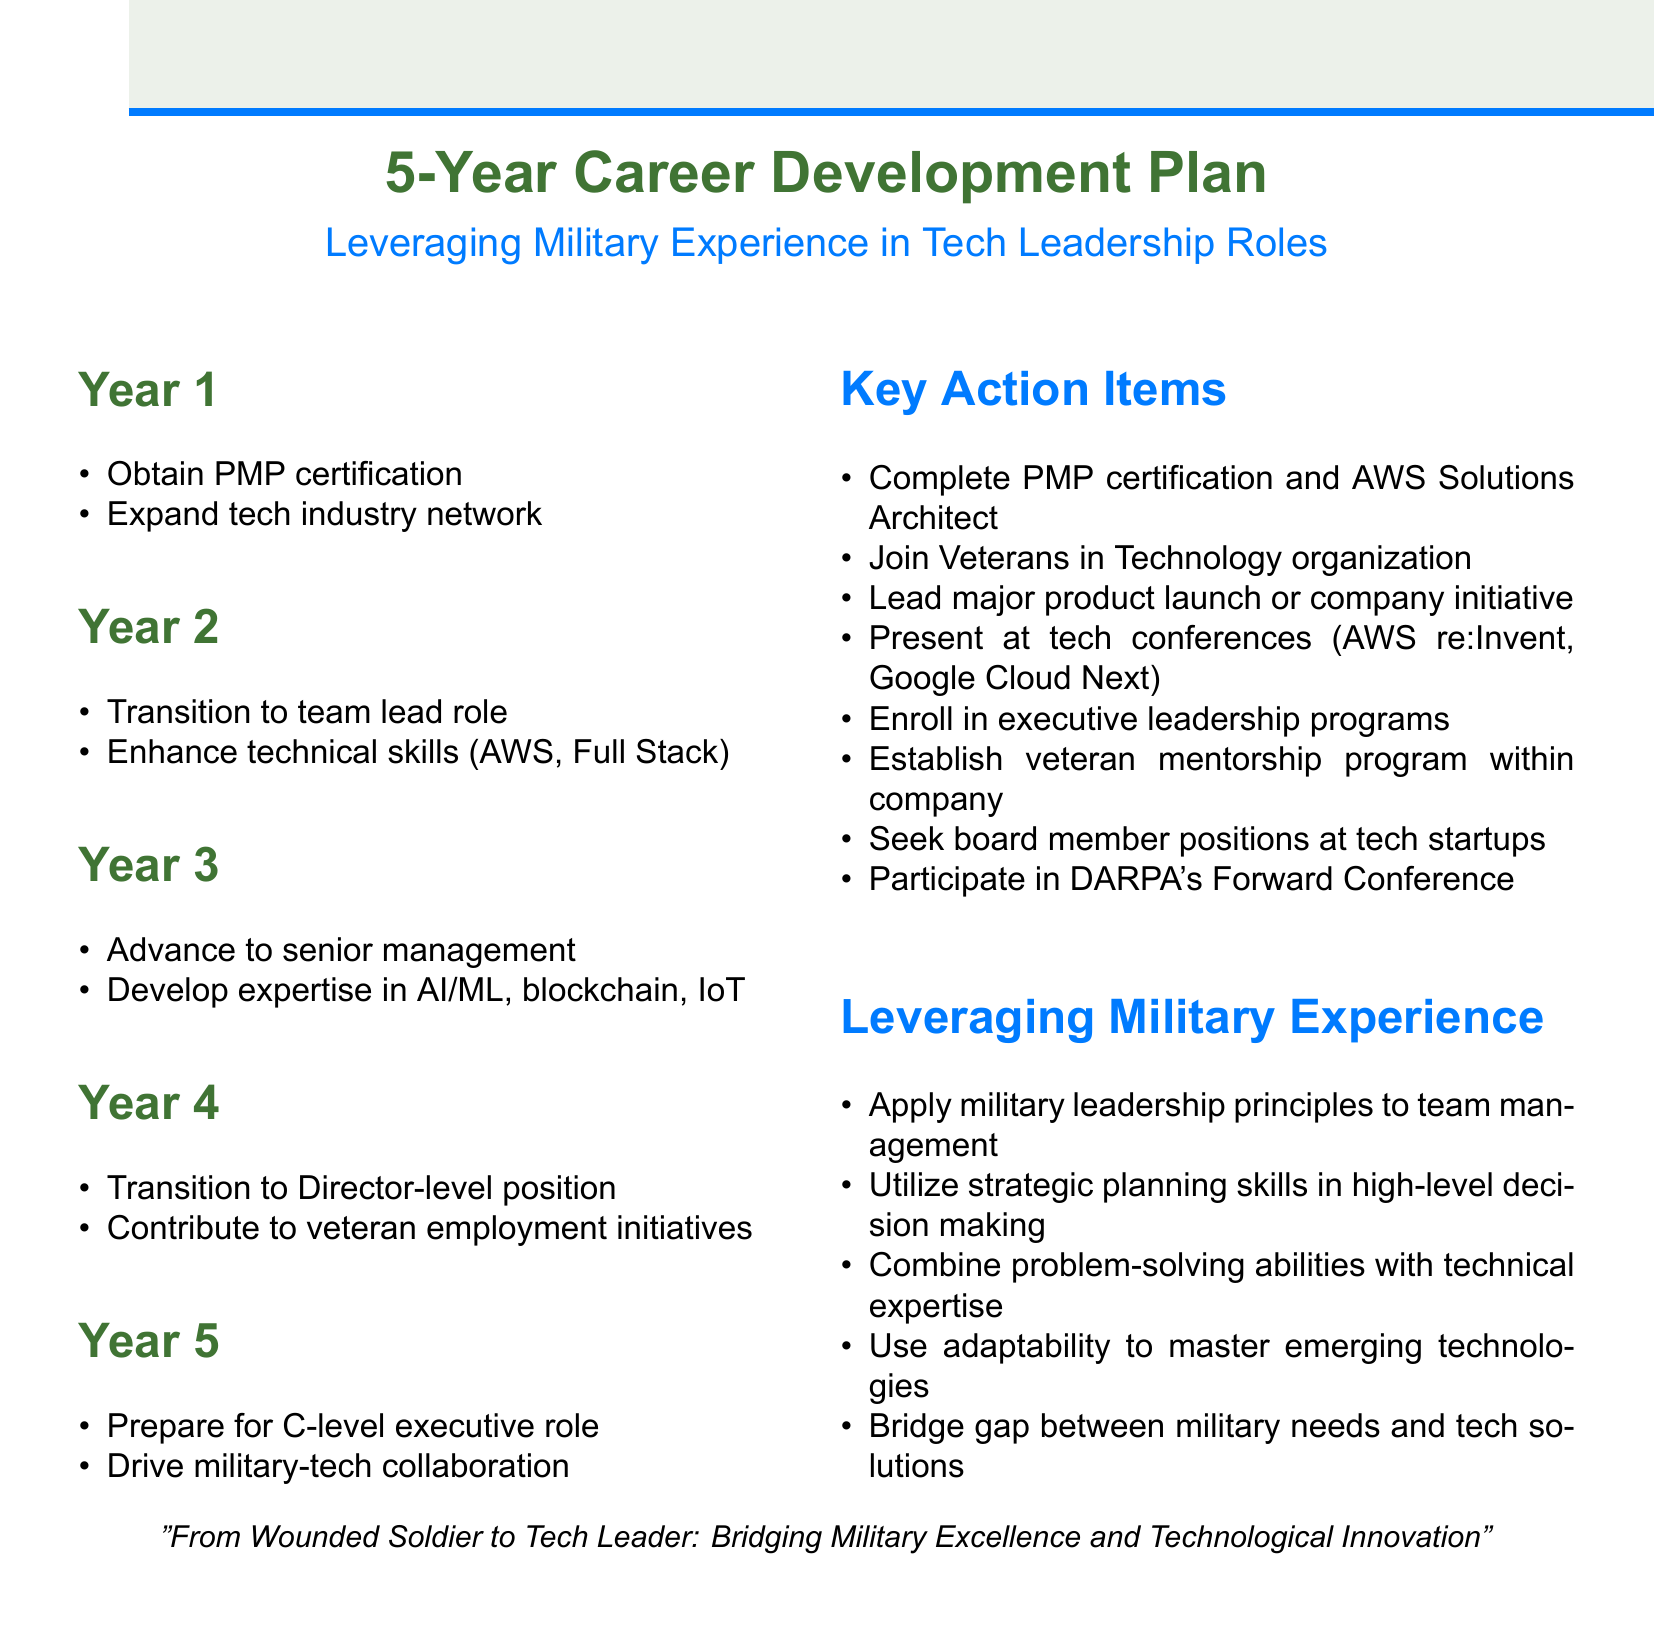What certification is targeted in Year 1? In Year 1, the goal is to obtain the Project Management Professional (PMP) certification.
Answer: PMP certification What initiative is mentioned for veteran employment in Year 4? In Year 4, the document mentions contributing to veteran employment initiatives such as partnering with Hire Heroes USA.
Answer: Veteran employment initiatives Which technology is focused on in Year 3? In Year 3, the focus is on developing expertise in emerging technologies such as artificial intelligence and machine learning.
Answer: Artificial intelligence and machine learning What is one action item for enhancing technical skills in Year 2? One of the action items listed for enhancing technical skills in Year 2 is obtaining the AWS Certified Solutions Architect certification.
Answer: AWS Certified Solutions Architect certification What is the main aim of Year 5? The main aim of Year 5 is to prepare for a C-level executive role.
Answer: C-level executive role Which organization should be joined in Year 1? The organization that should be joined in Year 1 is Veterans in Technology (VIT).
Answer: Veterans in Technology (VIT) How many years does this career development plan cover? The career development plan covers a total of five years.
Answer: Five years What is a key action item to contribute to military-tech collaboration? A key action item to contribute to military-tech collaboration is participating in DARPA's Forward Conference.
Answer: DARPA's Forward Conference 